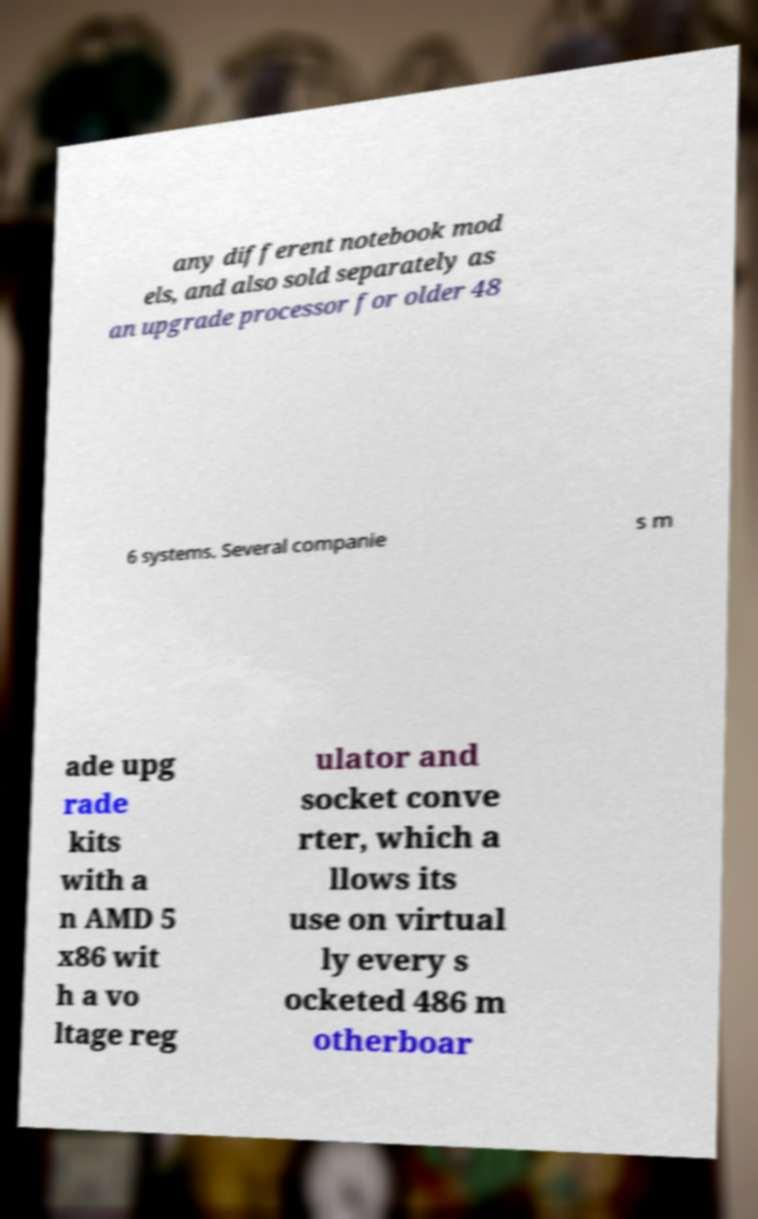I need the written content from this picture converted into text. Can you do that? any different notebook mod els, and also sold separately as an upgrade processor for older 48 6 systems. Several companie s m ade upg rade kits with a n AMD 5 x86 wit h a vo ltage reg ulator and socket conve rter, which a llows its use on virtual ly every s ocketed 486 m otherboar 